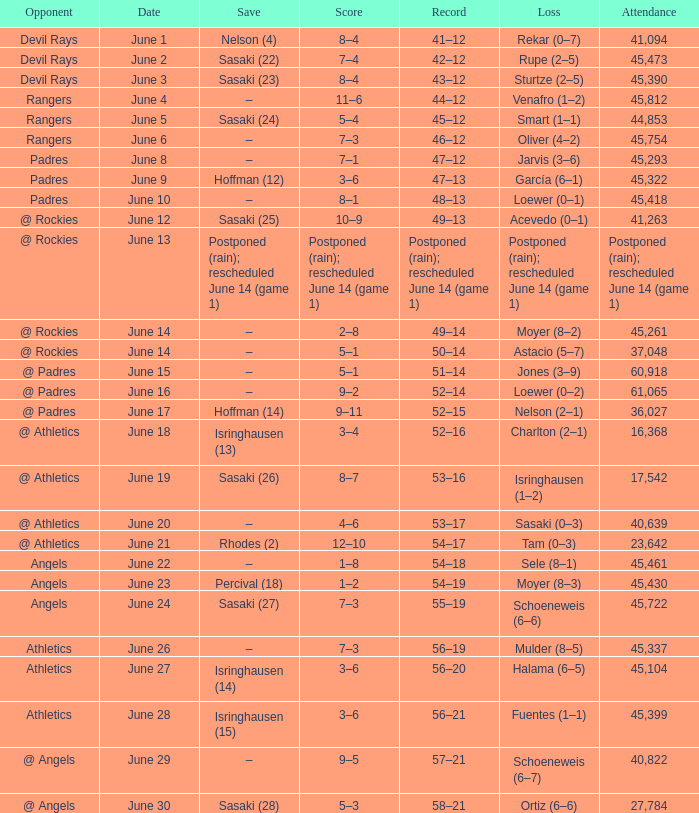What was the date of the Mariners game when they had a record of 53–17? June 20. 